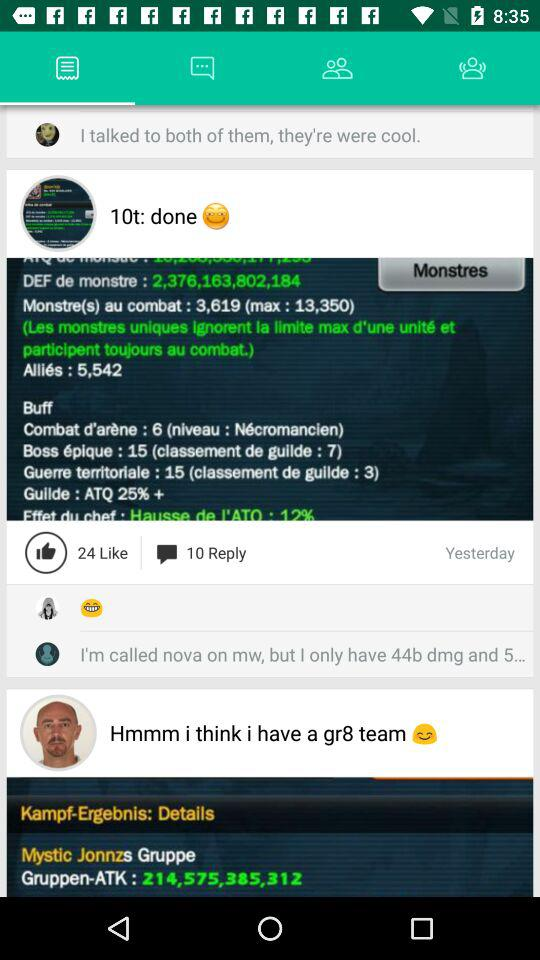How many likes are there? There are 24 likes. 